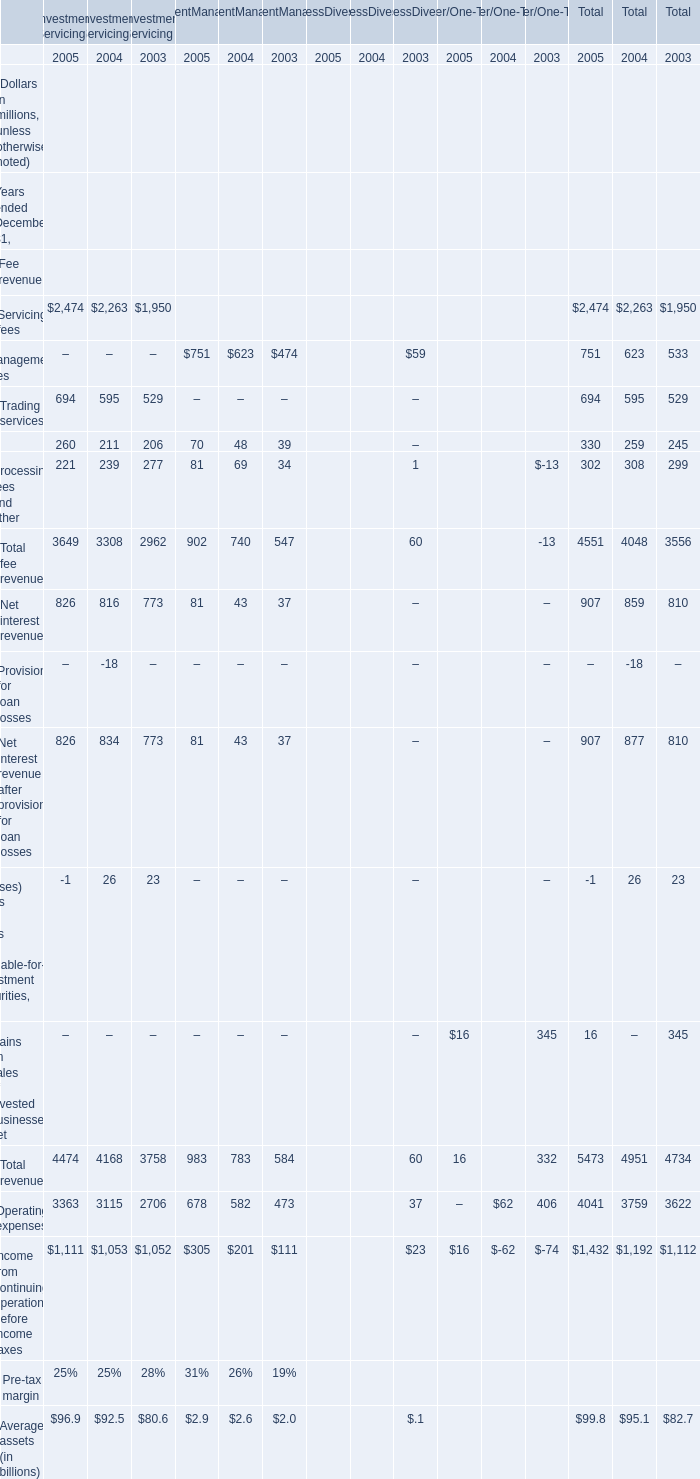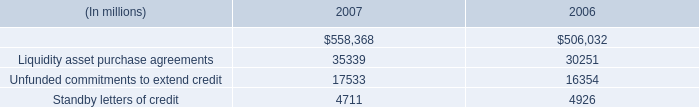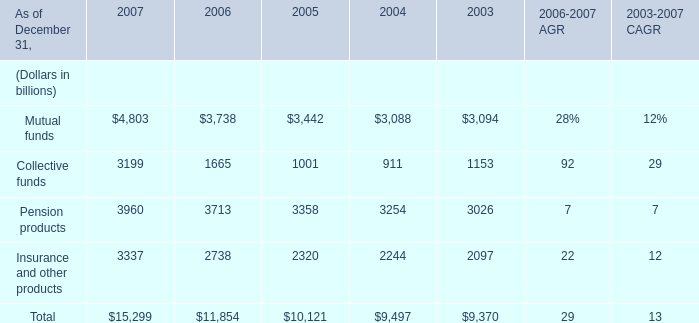What's the sum of Collective funds of 2006, Indemnified securities financing of 2006, and Total of 2003 ? 
Computations: ((1665.0 + 506032.0) + 9370.0)
Answer: 517067.0. 